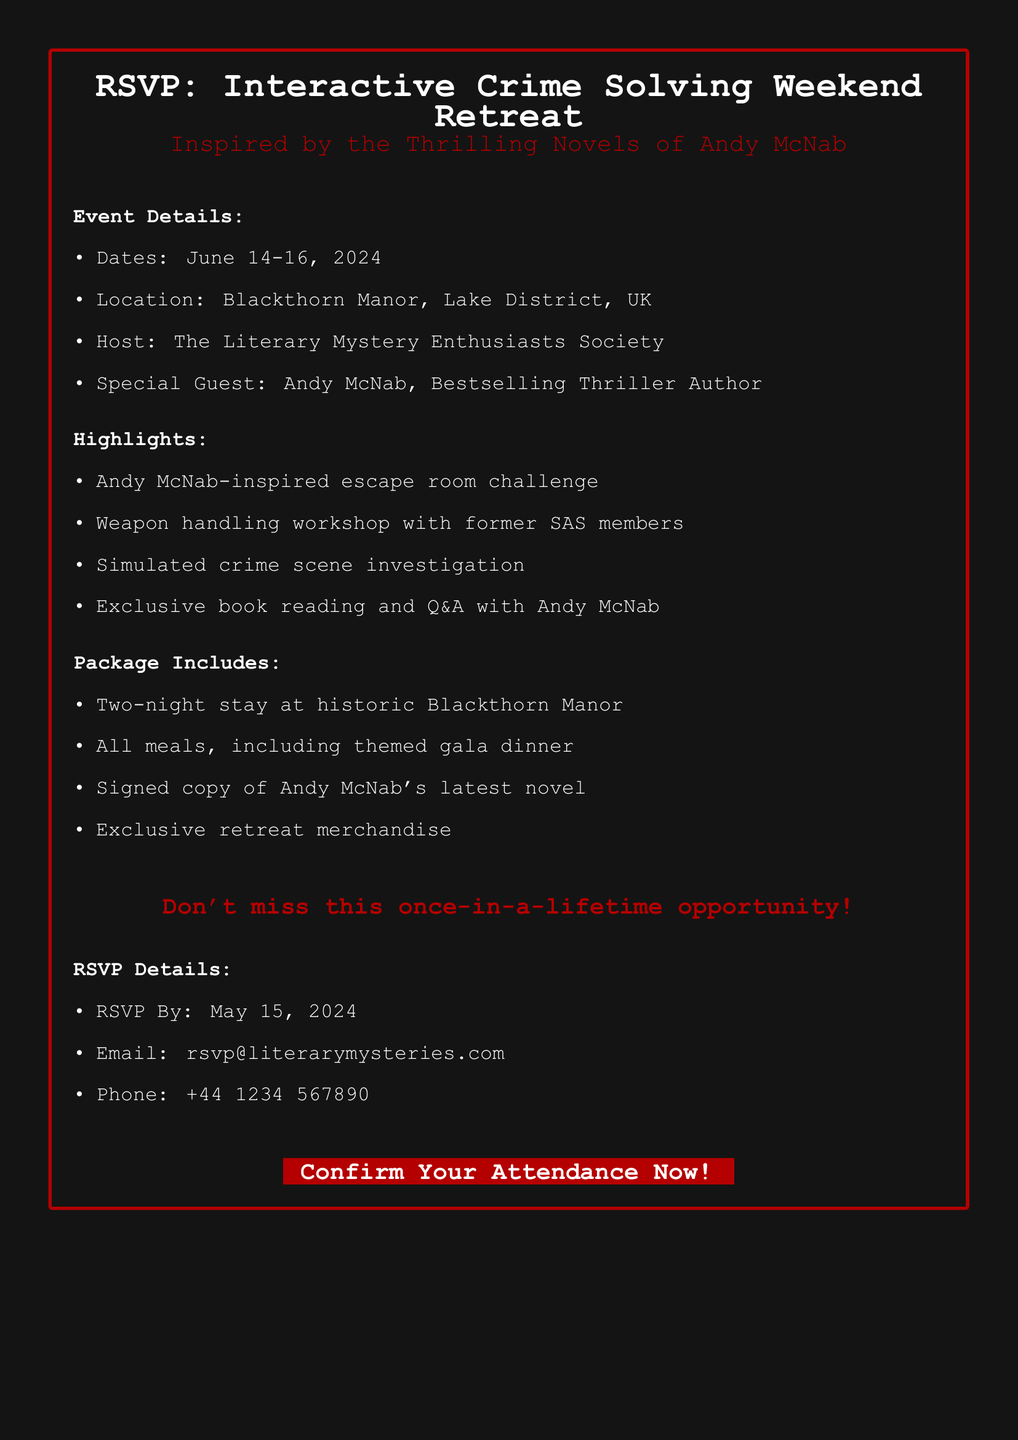What are the event dates? The event is scheduled for June 14-16, 2024, as mentioned in the document.
Answer: June 14-16, 2024 Where is the retreat located? The document specifies that the location of the retreat is Blackthorn Manor, Lake District, UK.
Answer: Blackthorn Manor, Lake District, UK Who is the special guest? The document states that the special guest is Andy McNab, Bestselling Thriller Author.
Answer: Andy McNab What workshop is included in the package? A weapon handling workshop with former SAS members is highlighted in the document.
Answer: Weapon handling workshop When is the RSVP deadline? The RSVP deadline is noted as May 15, 2024, in the document.
Answer: May 15, 2024 What kind of dinner is included in the package? The document mentions a themed gala dinner included in the package.
Answer: Themed gala dinner What should attendees expect as a part of the package? The items listed include a signed copy of Andy McNab's latest novel, which indicates what attendees can expect as part of the package.
Answer: Signed copy of Andy McNab's latest novel What organization is hosting the event? The document specifies that the host is The Literary Mystery Enthusiasts Society.
Answer: The Literary Mystery Enthusiasts Society What type of activities will attendees participate in? Activities indicated include an escape room challenge and simulated crime scene investigation, showing what attendees will participate in.
Answer: Escape room challenge and simulated crime scene investigation 